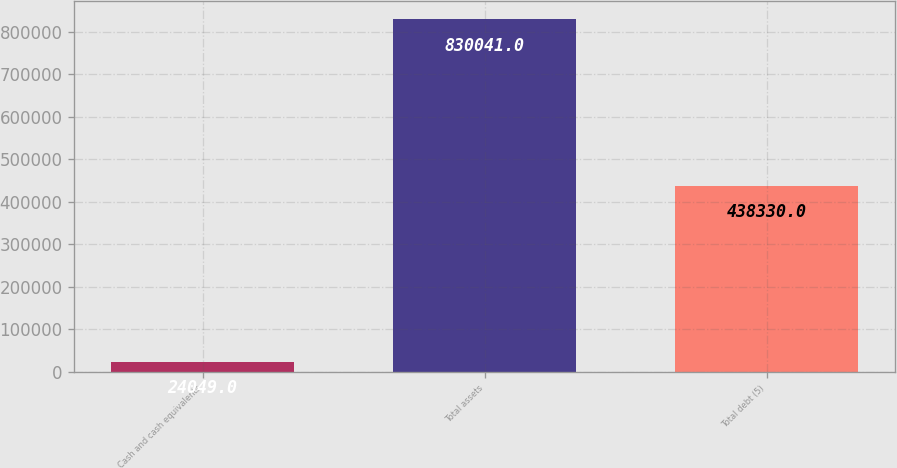<chart> <loc_0><loc_0><loc_500><loc_500><bar_chart><fcel>Cash and cash equivalents<fcel>Total assets<fcel>Total debt (5)<nl><fcel>24049<fcel>830041<fcel>438330<nl></chart> 